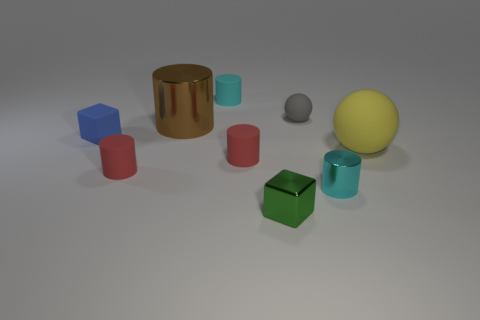What number of other objects are there of the same shape as the brown metallic object?
Make the answer very short. 4. The object that is to the left of the large metal cylinder and to the right of the blue matte cube is made of what material?
Provide a succinct answer. Rubber. How many things are either tiny cyan objects or big cylinders?
Your answer should be very brief. 3. Are there more big spheres than green metallic balls?
Keep it short and to the point. Yes. What size is the rubber cylinder that is left of the cyan object that is behind the tiny blue thing?
Give a very brief answer. Small. The tiny matte thing that is the same shape as the large rubber object is what color?
Ensure brevity in your answer.  Gray. The gray sphere is what size?
Your answer should be compact. Small. How many cylinders are large blue matte things or green things?
Your answer should be very brief. 0. What is the size of the rubber thing that is the same shape as the tiny green metal object?
Your answer should be compact. Small. What number of metallic cylinders are there?
Provide a short and direct response. 2. 